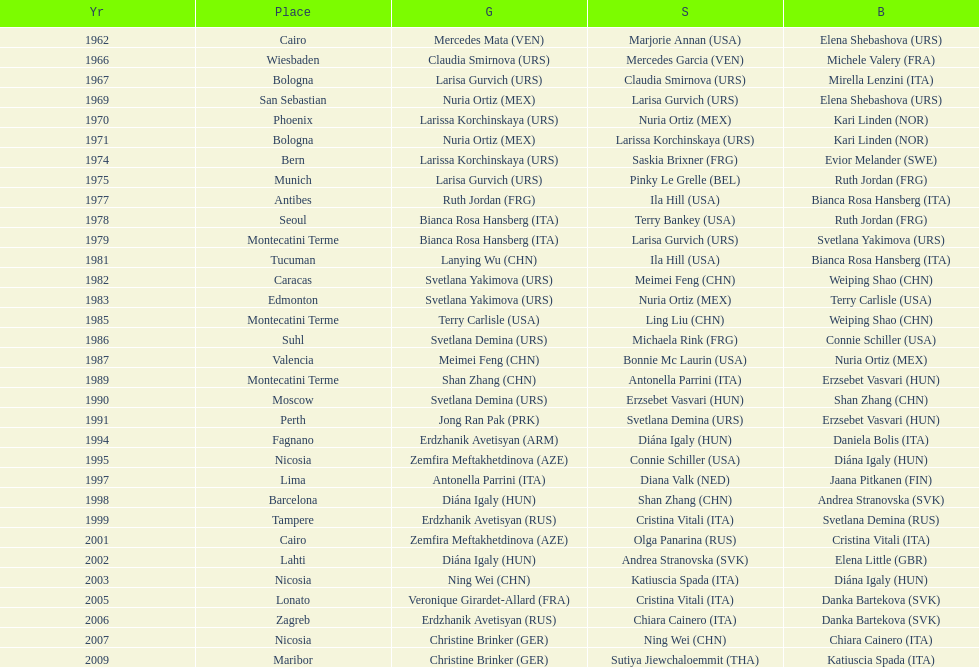What is the aggregate quantity of silver for cairo? 0. 